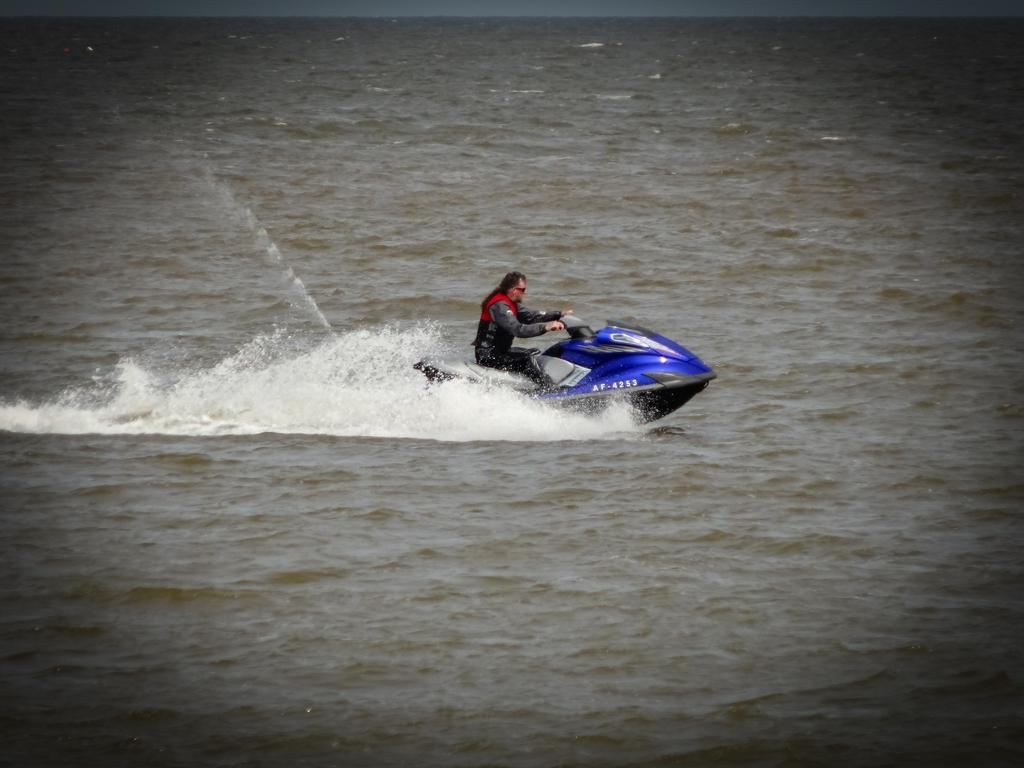Who is the main subject in the image? There is a man in the image. What is the man doing in the image? The man is riding a jet ski. Where is the jet ski located in the image? The jet ski is on the water surface. What time of day is the man's mother visiting him in the image? There is no mention of a mother or time of day in the image, as it only features a man riding a jet ski on the water surface. 